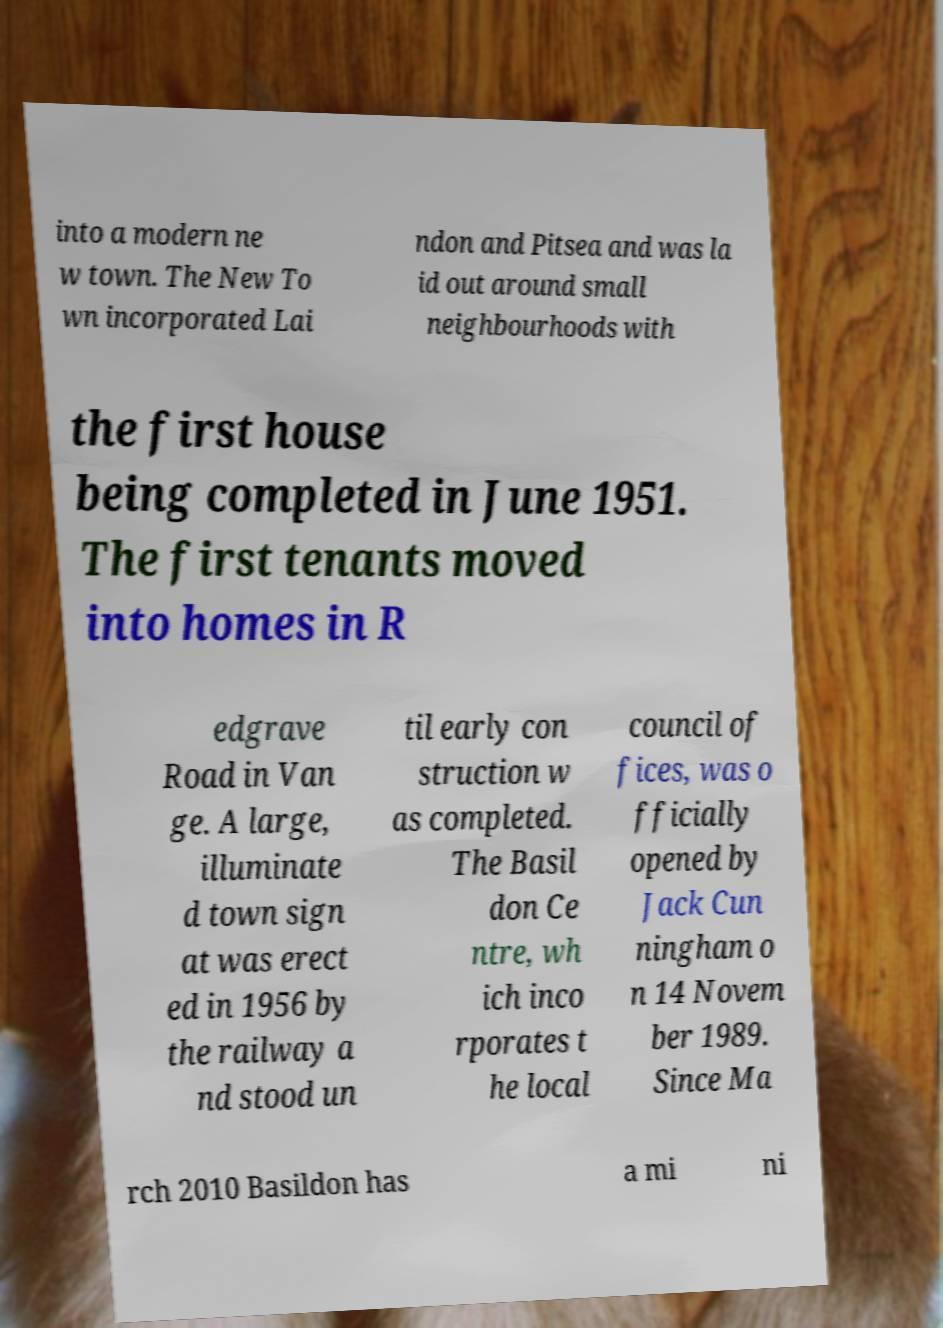For documentation purposes, I need the text within this image transcribed. Could you provide that? into a modern ne w town. The New To wn incorporated Lai ndon and Pitsea and was la id out around small neighbourhoods with the first house being completed in June 1951. The first tenants moved into homes in R edgrave Road in Van ge. A large, illuminate d town sign at was erect ed in 1956 by the railway a nd stood un til early con struction w as completed. The Basil don Ce ntre, wh ich inco rporates t he local council of fices, was o fficially opened by Jack Cun ningham o n 14 Novem ber 1989. Since Ma rch 2010 Basildon has a mi ni 